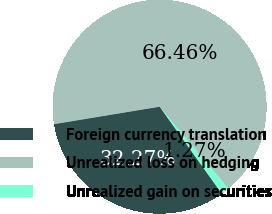Convert chart. <chart><loc_0><loc_0><loc_500><loc_500><pie_chart><fcel>Foreign currency translation<fcel>Unrealized loss on hedging<fcel>Unrealized gain on securities<nl><fcel>32.27%<fcel>66.46%<fcel>1.27%<nl></chart> 